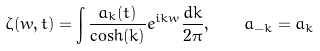Convert formula to latex. <formula><loc_0><loc_0><loc_500><loc_500>\zeta ( w , t ) = \int \frac { a _ { k } ( t ) } { \cosh ( k ) } e ^ { i k w } \frac { d k } { 2 \pi } , \quad a _ { - k } = \bar { a } _ { k }</formula> 